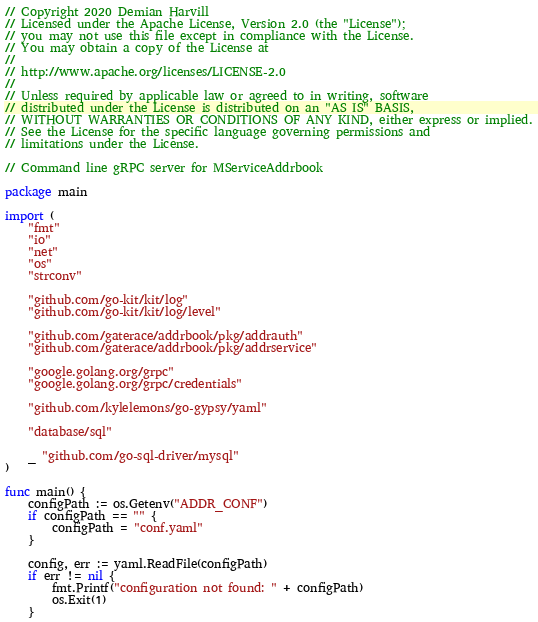<code> <loc_0><loc_0><loc_500><loc_500><_Go_>// Copyright 2020 Demian Harvill
// Licensed under the Apache License, Version 2.0 (the "License");
// you may not use this file except in compliance with the License.
// You may obtain a copy of the License at
//
// http://www.apache.org/licenses/LICENSE-2.0
//
// Unless required by applicable law or agreed to in writing, software
// distributed under the License is distributed on an "AS IS" BASIS,
// WITHOUT WARRANTIES OR CONDITIONS OF ANY KIND, either express or implied.
// See the License for the specific language governing permissions and
// limitations under the License.

// Command line gRPC server for MServiceAddrbook

package main

import (
	"fmt"
	"io"
	"net"
	"os"
	"strconv"

	"github.com/go-kit/kit/log"
	"github.com/go-kit/kit/log/level"

	"github.com/gaterace/addrbook/pkg/addrauth"
	"github.com/gaterace/addrbook/pkg/addrservice"

	"google.golang.org/grpc"
	"google.golang.org/grpc/credentials"

	"github.com/kylelemons/go-gypsy/yaml"

	"database/sql"

	_ "github.com/go-sql-driver/mysql"
)

func main() {
	configPath := os.Getenv("ADDR_CONF")
	if configPath == "" {
		configPath = "conf.yaml"
	}

	config, err := yaml.ReadFile(configPath)
	if err != nil {
		fmt.Printf("configuration not found: " + configPath)
		os.Exit(1)
	}
</code> 